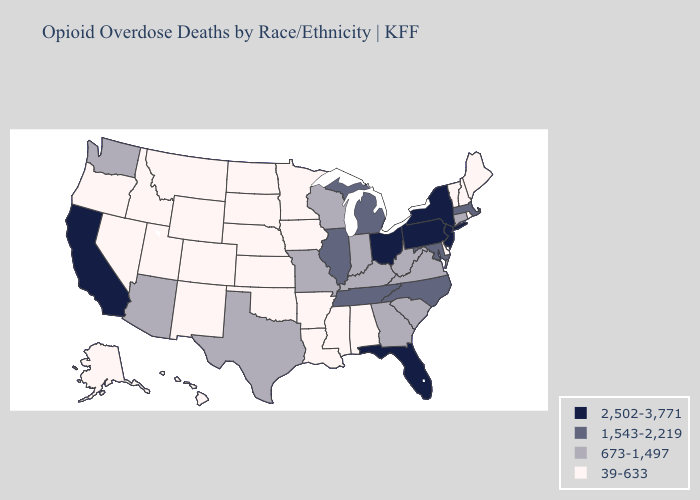Does Tennessee have a higher value than Montana?
Quick response, please. Yes. What is the highest value in states that border Indiana?
Give a very brief answer. 2,502-3,771. Does Michigan have a higher value than New Jersey?
Write a very short answer. No. Which states have the lowest value in the USA?
Keep it brief. Alabama, Alaska, Arkansas, Colorado, Delaware, Hawaii, Idaho, Iowa, Kansas, Louisiana, Maine, Minnesota, Mississippi, Montana, Nebraska, Nevada, New Hampshire, New Mexico, North Dakota, Oklahoma, Oregon, Rhode Island, South Dakota, Utah, Vermont, Wyoming. Which states have the lowest value in the MidWest?
Short answer required. Iowa, Kansas, Minnesota, Nebraska, North Dakota, South Dakota. What is the value of Nebraska?
Write a very short answer. 39-633. What is the lowest value in the USA?
Short answer required. 39-633. Which states have the lowest value in the West?
Short answer required. Alaska, Colorado, Hawaii, Idaho, Montana, Nevada, New Mexico, Oregon, Utah, Wyoming. Does Kansas have the lowest value in the MidWest?
Short answer required. Yes. Does Pennsylvania have the highest value in the Northeast?
Give a very brief answer. Yes. Name the states that have a value in the range 39-633?
Concise answer only. Alabama, Alaska, Arkansas, Colorado, Delaware, Hawaii, Idaho, Iowa, Kansas, Louisiana, Maine, Minnesota, Mississippi, Montana, Nebraska, Nevada, New Hampshire, New Mexico, North Dakota, Oklahoma, Oregon, Rhode Island, South Dakota, Utah, Vermont, Wyoming. What is the highest value in states that border Iowa?
Give a very brief answer. 1,543-2,219. Does North Carolina have the lowest value in the USA?
Write a very short answer. No. What is the highest value in the USA?
Concise answer only. 2,502-3,771. Name the states that have a value in the range 2,502-3,771?
Write a very short answer. California, Florida, New Jersey, New York, Ohio, Pennsylvania. 